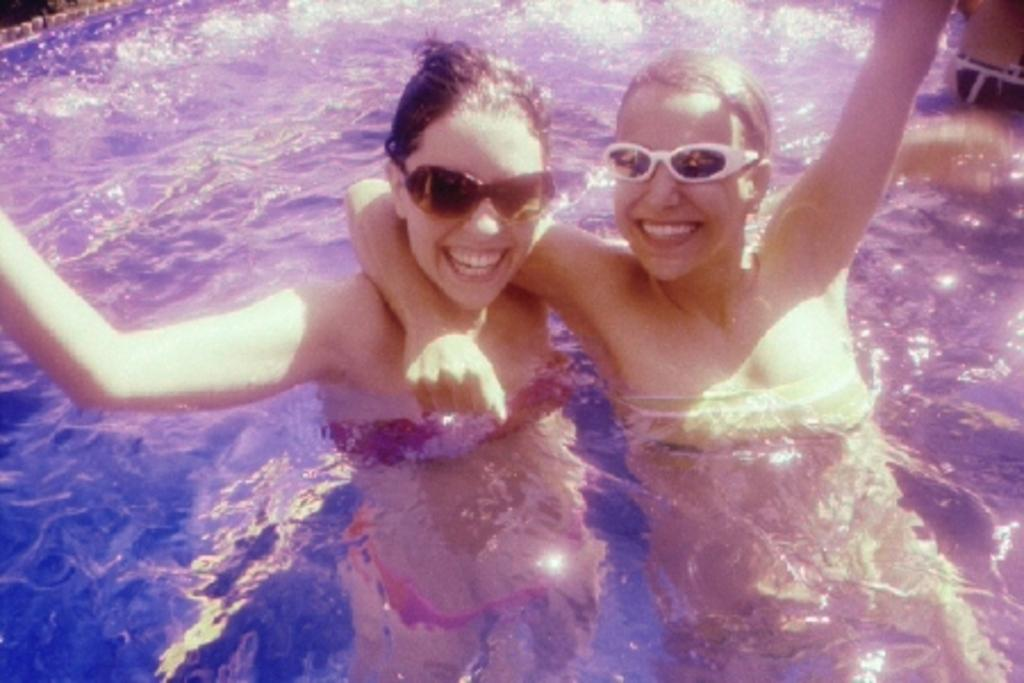What is the primary element present in the image? There is water in the image. Are there any people in the image? Yes, there are two persons standing in the water. What type of loaf is being held by the person on the left in the image? There is no loaf present in the image; it only features water and two persons standing in it. 